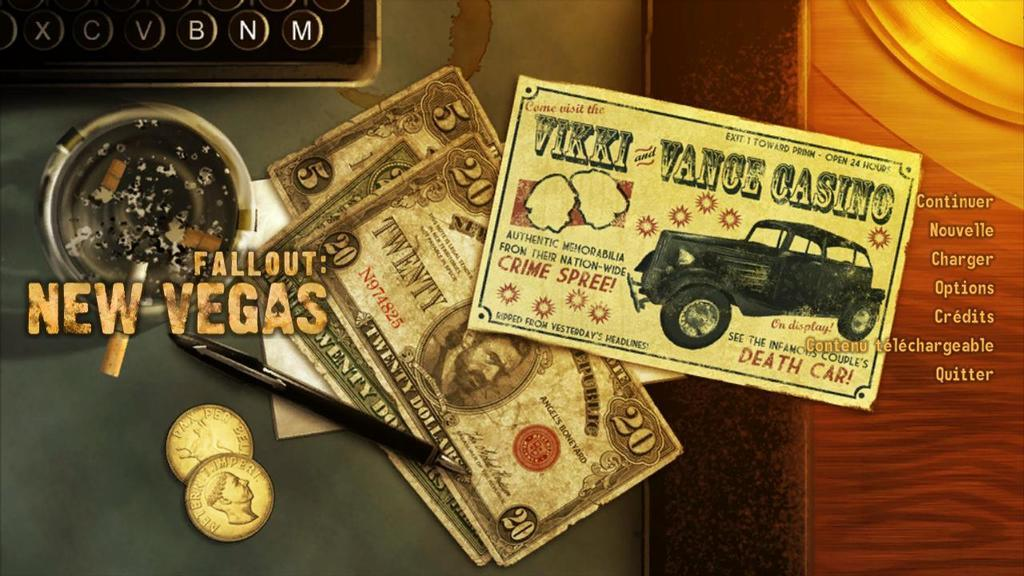<image>
Summarize the visual content of the image. The main menu screen for the game Fallout New Vegas 